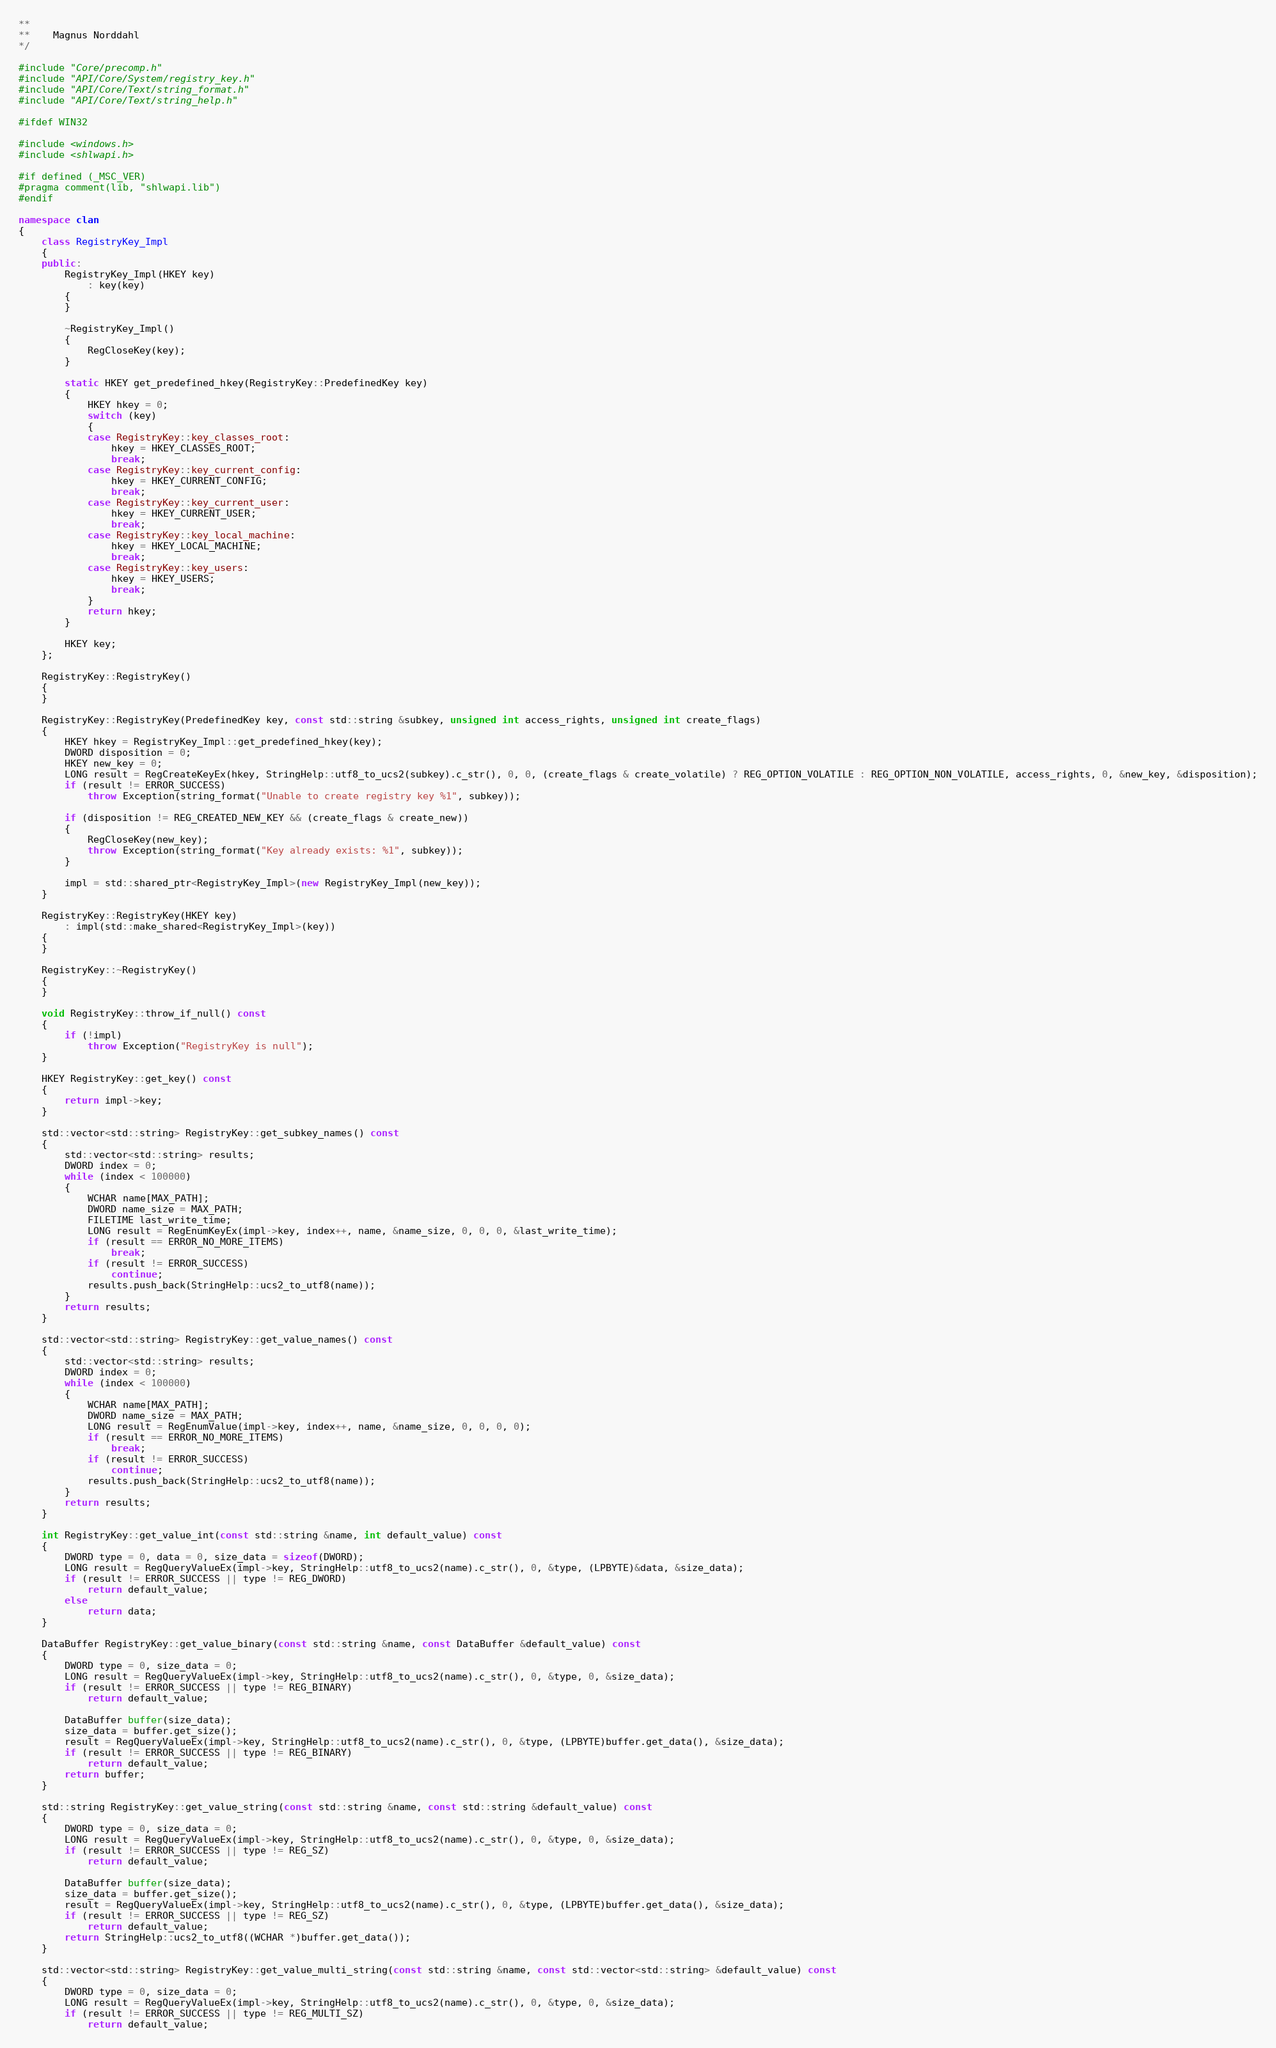<code> <loc_0><loc_0><loc_500><loc_500><_C++_>**
**    Magnus Norddahl
*/

#include "Core/precomp.h"
#include "API/Core/System/registry_key.h"
#include "API/Core/Text/string_format.h"
#include "API/Core/Text/string_help.h"

#ifdef WIN32

#include <windows.h>
#include <shlwapi.h>

#if defined (_MSC_VER)
#pragma comment(lib, "shlwapi.lib")
#endif

namespace clan
{
	class RegistryKey_Impl
	{
	public:
		RegistryKey_Impl(HKEY key)
			: key(key)
		{
		}

		~RegistryKey_Impl()
		{
			RegCloseKey(key);
		}

		static HKEY get_predefined_hkey(RegistryKey::PredefinedKey key)
		{
			HKEY hkey = 0;
			switch (key)
			{
			case RegistryKey::key_classes_root:
				hkey = HKEY_CLASSES_ROOT;
				break;
			case RegistryKey::key_current_config:
				hkey = HKEY_CURRENT_CONFIG;
				break;
			case RegistryKey::key_current_user:
				hkey = HKEY_CURRENT_USER;
				break;
			case RegistryKey::key_local_machine:
				hkey = HKEY_LOCAL_MACHINE;
				break;
			case RegistryKey::key_users:
				hkey = HKEY_USERS;
				break;
			}
			return hkey;
		}

		HKEY key;
	};

	RegistryKey::RegistryKey()
	{
	}

	RegistryKey::RegistryKey(PredefinedKey key, const std::string &subkey, unsigned int access_rights, unsigned int create_flags)
	{
		HKEY hkey = RegistryKey_Impl::get_predefined_hkey(key);
		DWORD disposition = 0;
		HKEY new_key = 0;
		LONG result = RegCreateKeyEx(hkey, StringHelp::utf8_to_ucs2(subkey).c_str(), 0, 0, (create_flags & create_volatile) ? REG_OPTION_VOLATILE : REG_OPTION_NON_VOLATILE, access_rights, 0, &new_key, &disposition);
		if (result != ERROR_SUCCESS)
			throw Exception(string_format("Unable to create registry key %1", subkey));

		if (disposition != REG_CREATED_NEW_KEY && (create_flags & create_new))
		{
			RegCloseKey(new_key);
			throw Exception(string_format("Key already exists: %1", subkey));
		}

		impl = std::shared_ptr<RegistryKey_Impl>(new RegistryKey_Impl(new_key));
	}

	RegistryKey::RegistryKey(HKEY key)
		: impl(std::make_shared<RegistryKey_Impl>(key))
	{
	}

	RegistryKey::~RegistryKey()
	{
	}

	void RegistryKey::throw_if_null() const
	{
		if (!impl)
			throw Exception("RegistryKey is null");
	}

	HKEY RegistryKey::get_key() const
	{
		return impl->key;
	}

	std::vector<std::string> RegistryKey::get_subkey_names() const
	{
		std::vector<std::string> results;
		DWORD index = 0;
		while (index < 100000)
		{
			WCHAR name[MAX_PATH];
			DWORD name_size = MAX_PATH;
			FILETIME last_write_time;
			LONG result = RegEnumKeyEx(impl->key, index++, name, &name_size, 0, 0, 0, &last_write_time);
			if (result == ERROR_NO_MORE_ITEMS)
				break;
			if (result != ERROR_SUCCESS)
				continue;
			results.push_back(StringHelp::ucs2_to_utf8(name));
		}
		return results;
	}

	std::vector<std::string> RegistryKey::get_value_names() const
	{
		std::vector<std::string> results;
		DWORD index = 0;
		while (index < 100000)
		{
			WCHAR name[MAX_PATH];
			DWORD name_size = MAX_PATH;
			LONG result = RegEnumValue(impl->key, index++, name, &name_size, 0, 0, 0, 0);
			if (result == ERROR_NO_MORE_ITEMS)
				break;
			if (result != ERROR_SUCCESS)
				continue;
			results.push_back(StringHelp::ucs2_to_utf8(name));
		}
		return results;
	}

	int RegistryKey::get_value_int(const std::string &name, int default_value) const
	{
		DWORD type = 0, data = 0, size_data = sizeof(DWORD);
		LONG result = RegQueryValueEx(impl->key, StringHelp::utf8_to_ucs2(name).c_str(), 0, &type, (LPBYTE)&data, &size_data);
		if (result != ERROR_SUCCESS || type != REG_DWORD)
			return default_value;
		else
			return data;
	}

	DataBuffer RegistryKey::get_value_binary(const std::string &name, const DataBuffer &default_value) const
	{
		DWORD type = 0, size_data = 0;
		LONG result = RegQueryValueEx(impl->key, StringHelp::utf8_to_ucs2(name).c_str(), 0, &type, 0, &size_data);
		if (result != ERROR_SUCCESS || type != REG_BINARY)
			return default_value;

		DataBuffer buffer(size_data);
		size_data = buffer.get_size();
		result = RegQueryValueEx(impl->key, StringHelp::utf8_to_ucs2(name).c_str(), 0, &type, (LPBYTE)buffer.get_data(), &size_data);
		if (result != ERROR_SUCCESS || type != REG_BINARY)
			return default_value;
		return buffer;
	}

	std::string RegistryKey::get_value_string(const std::string &name, const std::string &default_value) const
	{
		DWORD type = 0, size_data = 0;
		LONG result = RegQueryValueEx(impl->key, StringHelp::utf8_to_ucs2(name).c_str(), 0, &type, 0, &size_data);
		if (result != ERROR_SUCCESS || type != REG_SZ)
			return default_value;

		DataBuffer buffer(size_data);
		size_data = buffer.get_size();
		result = RegQueryValueEx(impl->key, StringHelp::utf8_to_ucs2(name).c_str(), 0, &type, (LPBYTE)buffer.get_data(), &size_data);
		if (result != ERROR_SUCCESS || type != REG_SZ)
			return default_value;
		return StringHelp::ucs2_to_utf8((WCHAR *)buffer.get_data());
	}

	std::vector<std::string> RegistryKey::get_value_multi_string(const std::string &name, const std::vector<std::string> &default_value) const
	{
		DWORD type = 0, size_data = 0;
		LONG result = RegQueryValueEx(impl->key, StringHelp::utf8_to_ucs2(name).c_str(), 0, &type, 0, &size_data);
		if (result != ERROR_SUCCESS || type != REG_MULTI_SZ)
			return default_value;
</code> 